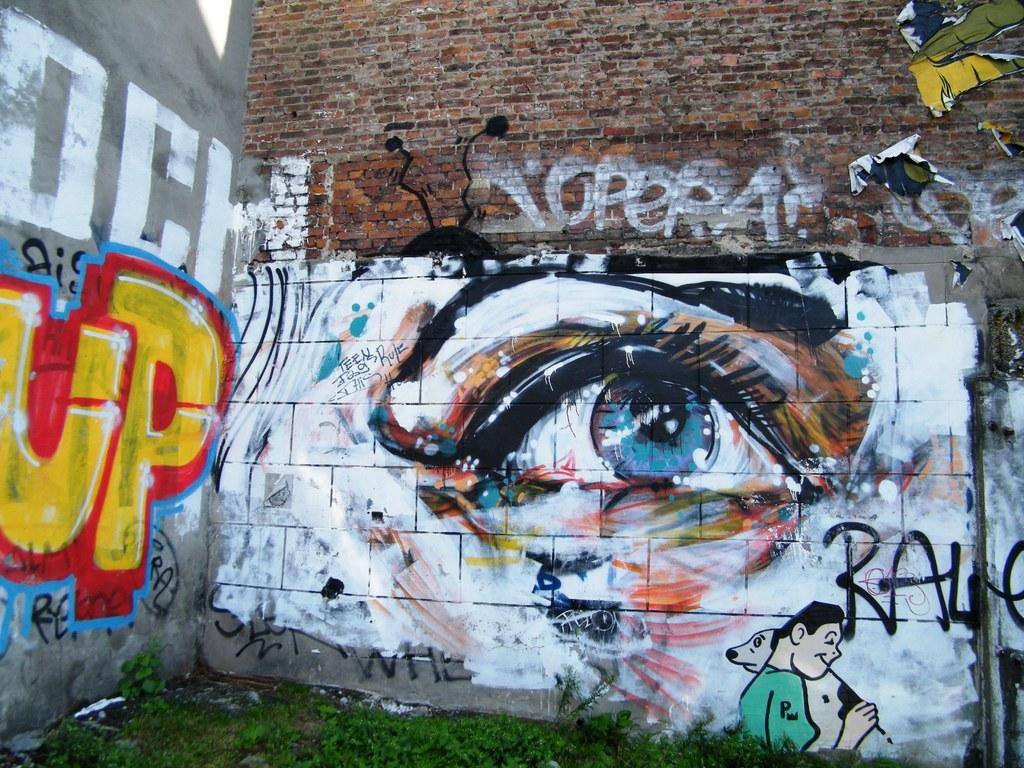What can be seen on the walls in the image? There are walls with graffiti paints in the image. What type of surface is on the ground in the image? There is grass on the ground in the image. What is the income of the person who created the graffiti in the image? There is no information about the person who created the graffiti or their income in the image. 